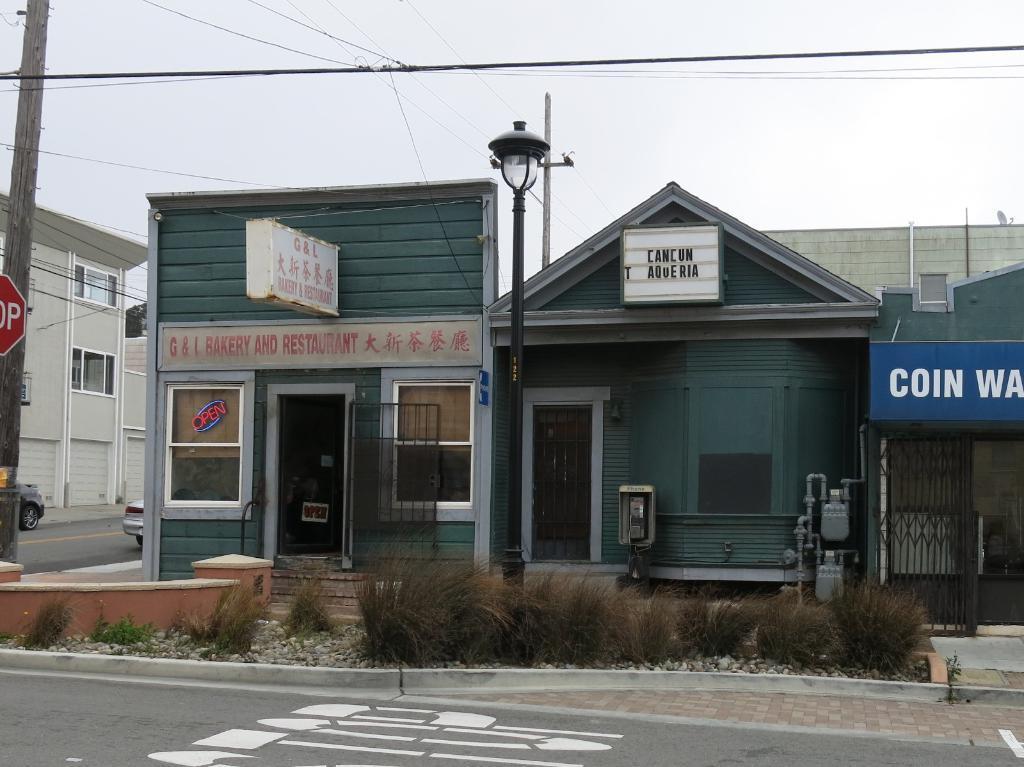Please provide a concise description of this image. In the image there is home in the back with a road in front of it and there is a electric pole on left side and above its sky. 